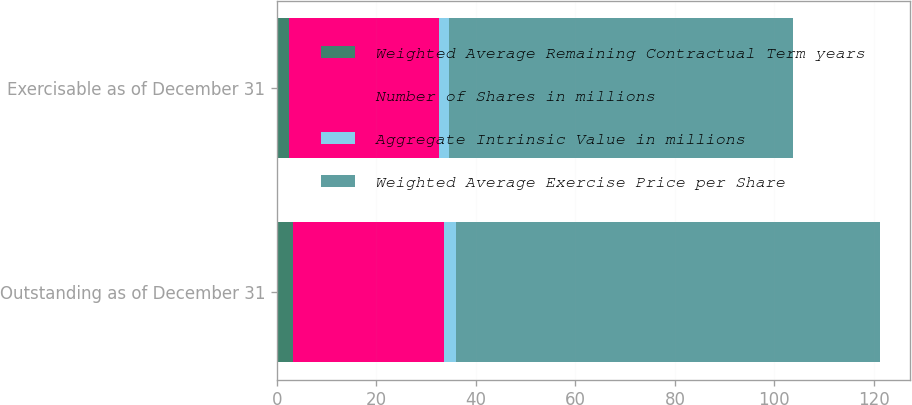<chart> <loc_0><loc_0><loc_500><loc_500><stacked_bar_chart><ecel><fcel>Outstanding as of December 31<fcel>Exercisable as of December 31<nl><fcel>Weighted Average Remaining Contractual Term years<fcel>3.2<fcel>2.5<nl><fcel>Number of Shares in millions<fcel>30.35<fcel>29.97<nl><fcel>Aggregate Intrinsic Value in millions<fcel>2.4<fcel>2.2<nl><fcel>Weighted Average Exercise Price per Share<fcel>85.2<fcel>69<nl></chart> 